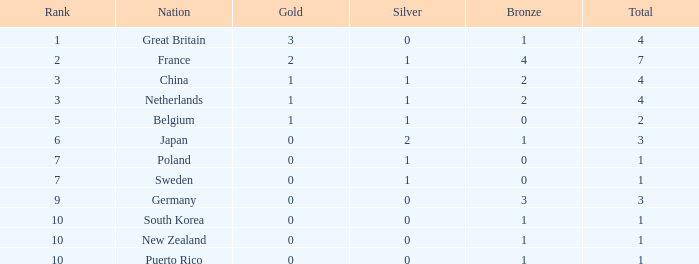What is the total where the gold is larger than 2? 1.0. 